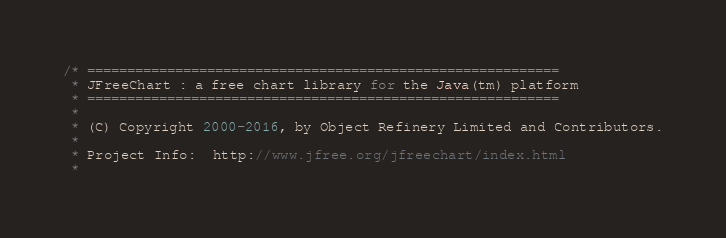<code> <loc_0><loc_0><loc_500><loc_500><_Java_>/* ===========================================================
 * JFreeChart : a free chart library for the Java(tm) platform
 * ===========================================================
 *
 * (C) Copyright 2000-2016, by Object Refinery Limited and Contributors.
 *
 * Project Info:  http://www.jfree.org/jfreechart/index.html
 *</code> 